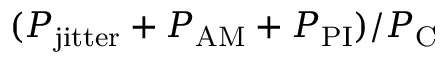<formula> <loc_0><loc_0><loc_500><loc_500>( P _ { j i t t e r } + P _ { A M } + P _ { P I } ) / P _ { C }</formula> 